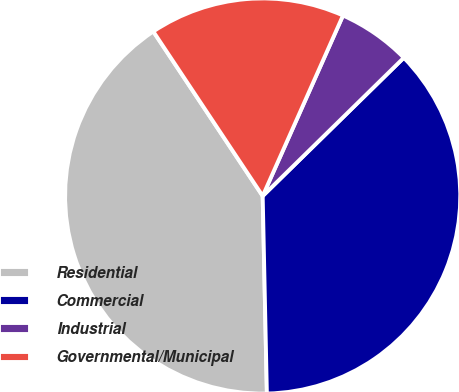Convert chart to OTSL. <chart><loc_0><loc_0><loc_500><loc_500><pie_chart><fcel>Residential<fcel>Commercial<fcel>Industrial<fcel>Governmental/Municipal<nl><fcel>41.0%<fcel>37.0%<fcel>6.0%<fcel>16.0%<nl></chart> 